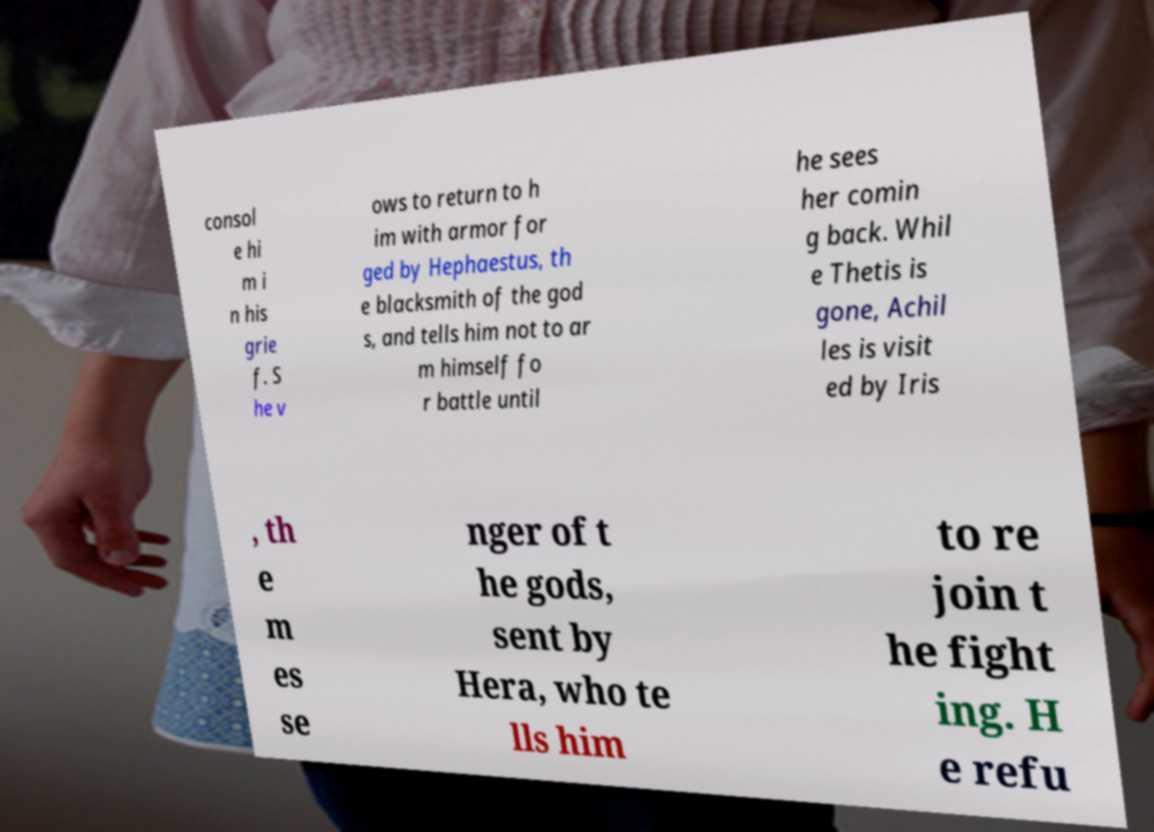There's text embedded in this image that I need extracted. Can you transcribe it verbatim? consol e hi m i n his grie f. S he v ows to return to h im with armor for ged by Hephaestus, th e blacksmith of the god s, and tells him not to ar m himself fo r battle until he sees her comin g back. Whil e Thetis is gone, Achil les is visit ed by Iris , th e m es se nger of t he gods, sent by Hera, who te lls him to re join t he fight ing. H e refu 